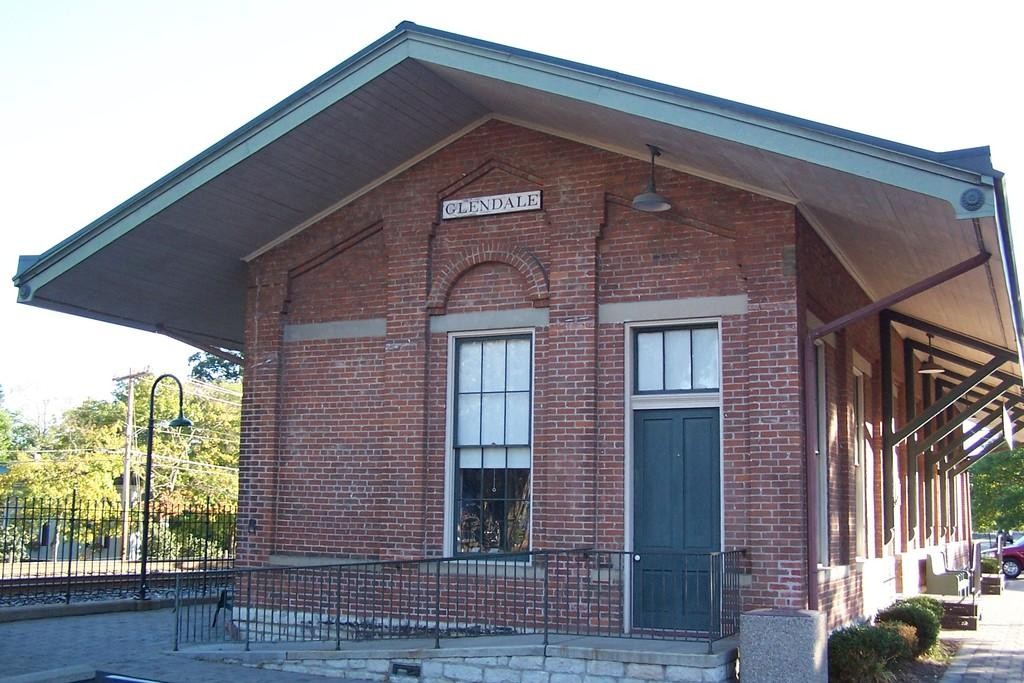What type of structure is visible in the image? There is a house in the image. What is located near the house? There is fencing in the image. What type of vegetation can be seen in the image? There are green trees in the image. What is visible at the top of the image? The sky is visible at the top of the image. How many dinosaurs can be seen roaming around the house in the image? There are no dinosaurs present in the image. What type of ink is used to draw the base of the house in the image? The image is a photograph and does not involve ink or drawing. 